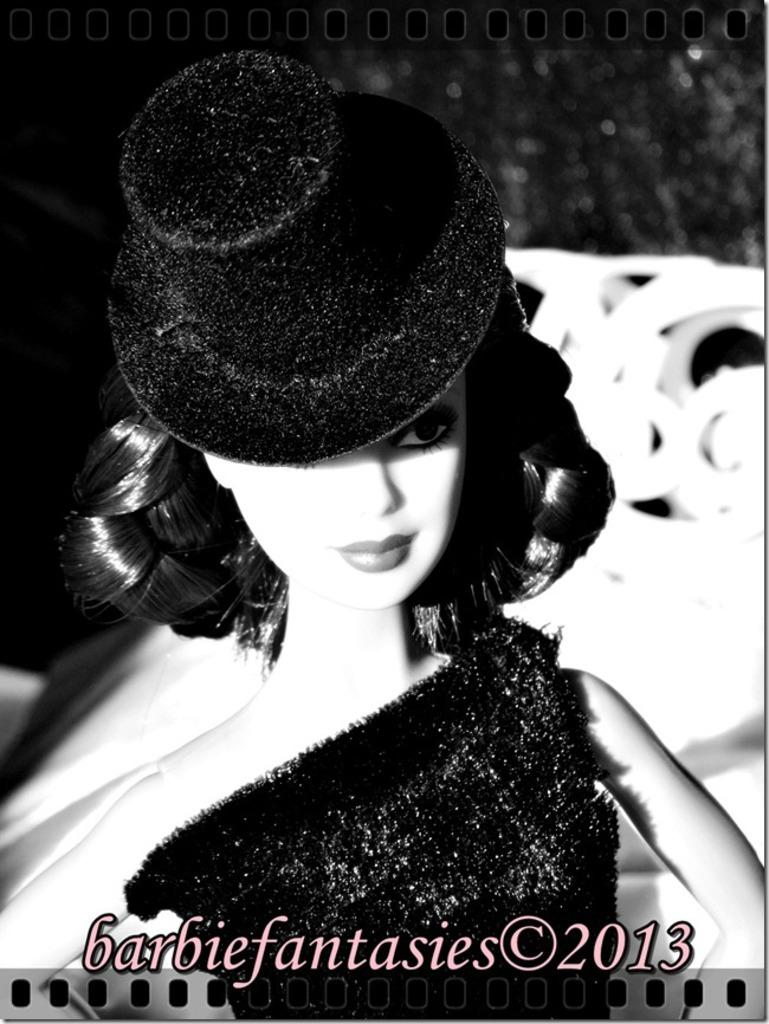What is the main subject of the image? There is a doll in the image. Can you describe the background of the image? The background of the image is dark and blurred. Is there any text or writing in the image? Yes, there is something written at the bottom of the image. What type of laborer can be seen working in the background of the image? There is no laborer present in the image; the background is dark and blurred. What cast member is responsible for the doll's creation in the image? The image does not provide information about the doll's creation or any cast members involved. 